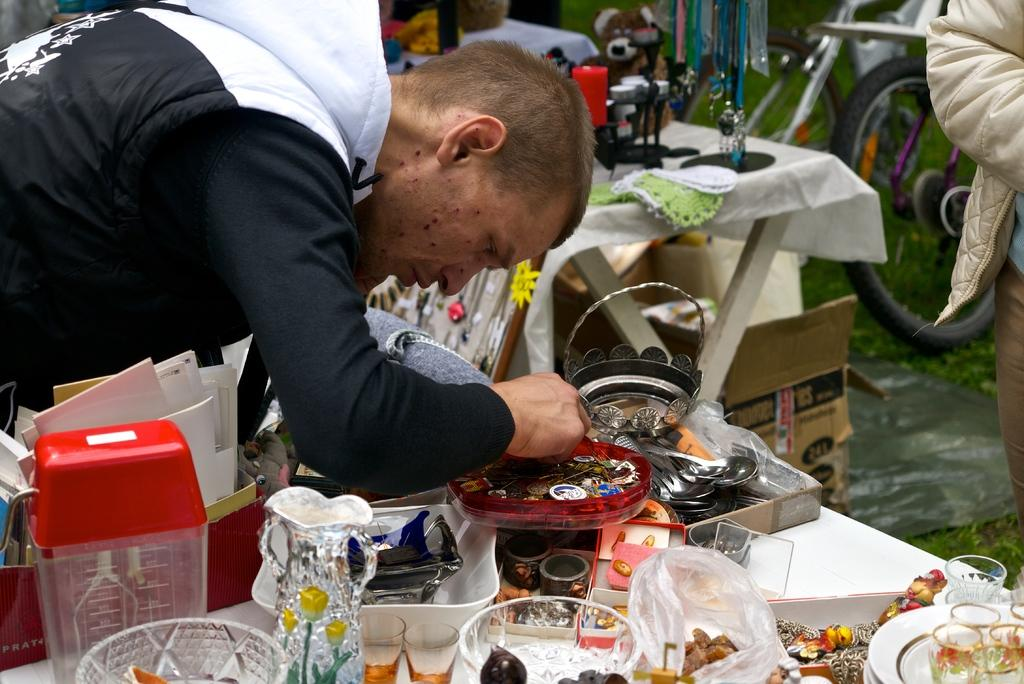What is the main subject of the image? There is a man standing in the image. How is the man positioned in the image? The man is bent. What is the man doing in the image? The man is doing something in a tray. What can be seen in the background of the image? There are many things on a table in the background of the image. What type of twig is the man holding in the image? There is no twig present in the image; the man is doing something in a tray. Can you tell me how many arches are visible in the image? There is no mention of arches in the image; the focus is on the man and the tray. 